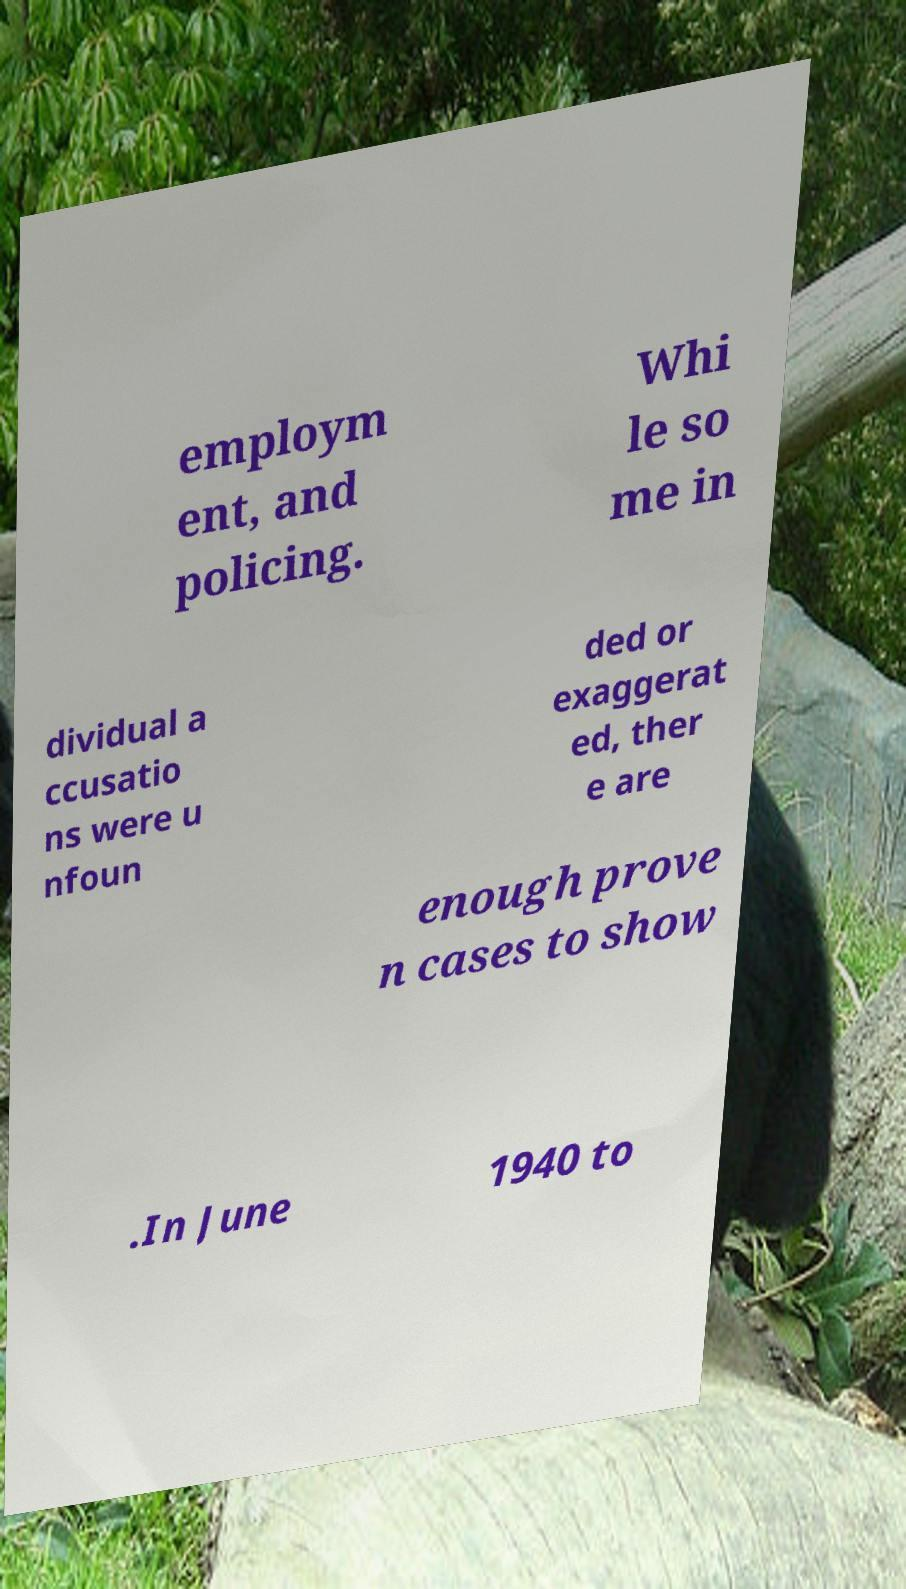There's text embedded in this image that I need extracted. Can you transcribe it verbatim? employm ent, and policing. Whi le so me in dividual a ccusatio ns were u nfoun ded or exaggerat ed, ther e are enough prove n cases to show .In June 1940 to 